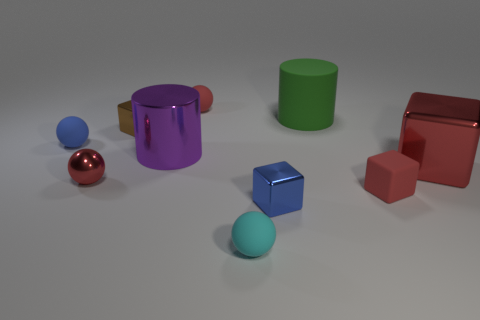Which objects in the scene would fit into one another? The large purple cylinder looks wide enough for the small maroon cube and possibly the small blue sphere to fit inside. Additionally, the large green cylinder might accommodate the small cyan sphere or possibly the brown rectangular prism if placed correctly. 